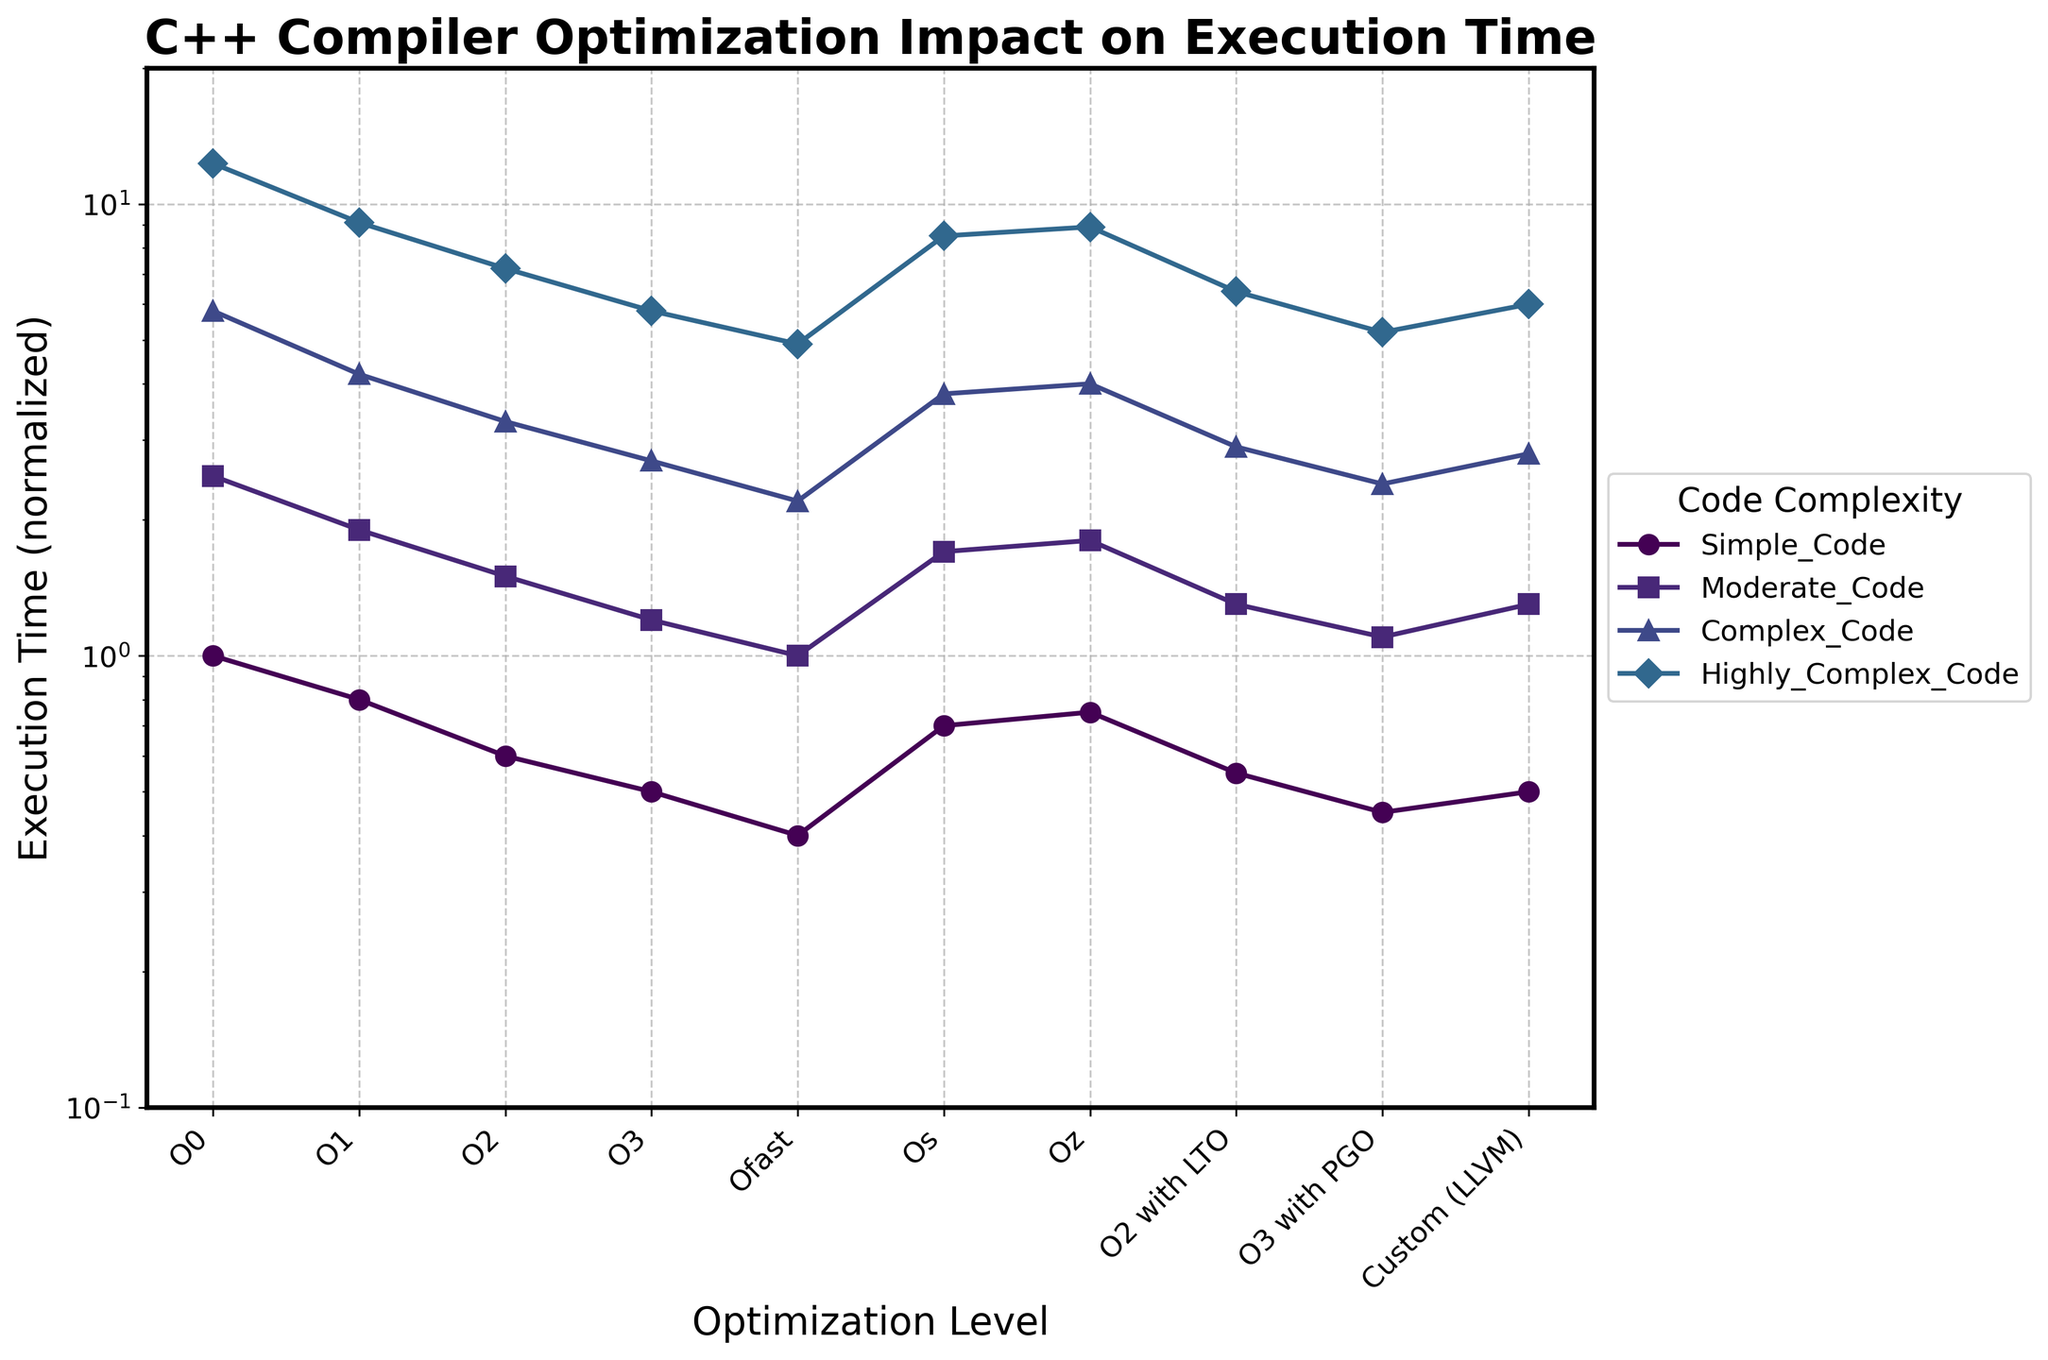Which optimization level has the lowest execution time for complex code? By looking at the 'Complex_Code' line and identifying the lowest point, we see that 'Ofast' has the lowest normalized execution time at 2.2.
Answer: Ofast What is the difference in execution time between 'O3' and 'Os' for highly complex code? For 'Highly_Complex_Code', 'O3' has a time of 5.8 and 'Os' has a time of 8.5. The difference is 8.5 - 5.8 = 2.7.
Answer: 2.7 Among 'Simple_Code', which optimization level provides the highest execution time? For 'Simple_Code', the highest point is at 'O0' with a normalized execution time of 1.0.
Answer: O0 Which code complexity shows the largest improvement when moving from 'O0' to 'O3'? Calculate the difference for each code complexity: 
Simple_Code: 1.0 - 0.5 = 0.5 
Moderate_Code: 2.5 - 1.2 = 1.3 
Complex_Code: 5.8 - 2.7 = 3.1 
Highly_Complex_Code: 12.3 - 5.8 = 6.5 
'Highly_Complex_Code' shows the largest improvement with a difference of 6.5.
Answer: Highly_Complex_Code What is the average execution time of 'Complex_Code' across all optimization levels? Sum the times for 'Complex_Code': 5.8 (O0) + 4.2 (O1) + 3.3 (O2) + 2.7 (O3) + 2.2 (Ofast) + 3.8 (Os) + 4.0 (Oz) + 2.9 (O2 with LTO) + 2.4 (O3 with PGO) + 2.8 (Custom (LLVM)) = 34.1. There are 10 optimization levels, so the average is 34.1 / 10 = 3.41.
Answer: 3.41 For 'Moderate_Code', which optimization levels have execution times closer to 1.5? The 'Moderate_Code' execution times are: 
O0: 2.5 
O1: 1.9 
O2: 1.5 
O3: 1.2 
Ofast: 1.0 
Os: 1.7 
Oz: 1.8 
O2 with LTO: 1.3 
O3 with PGO: 1.1 
Custom (LLVM): 1.3 
'O2', 'O2 with LTO', and 'Custom (LLVM)' are closest to 1.5.
Answer: O2, O2 with LTO, Custom (LLVM) Which optimization level provides the most consistent reduction in execution time across all code complexities? By observing the lines representing each optimization level, 'O3' generally has consistently lower execution times across all code complexities compared to other levels, followed closely by 'Ofast'.
Answer: O3 